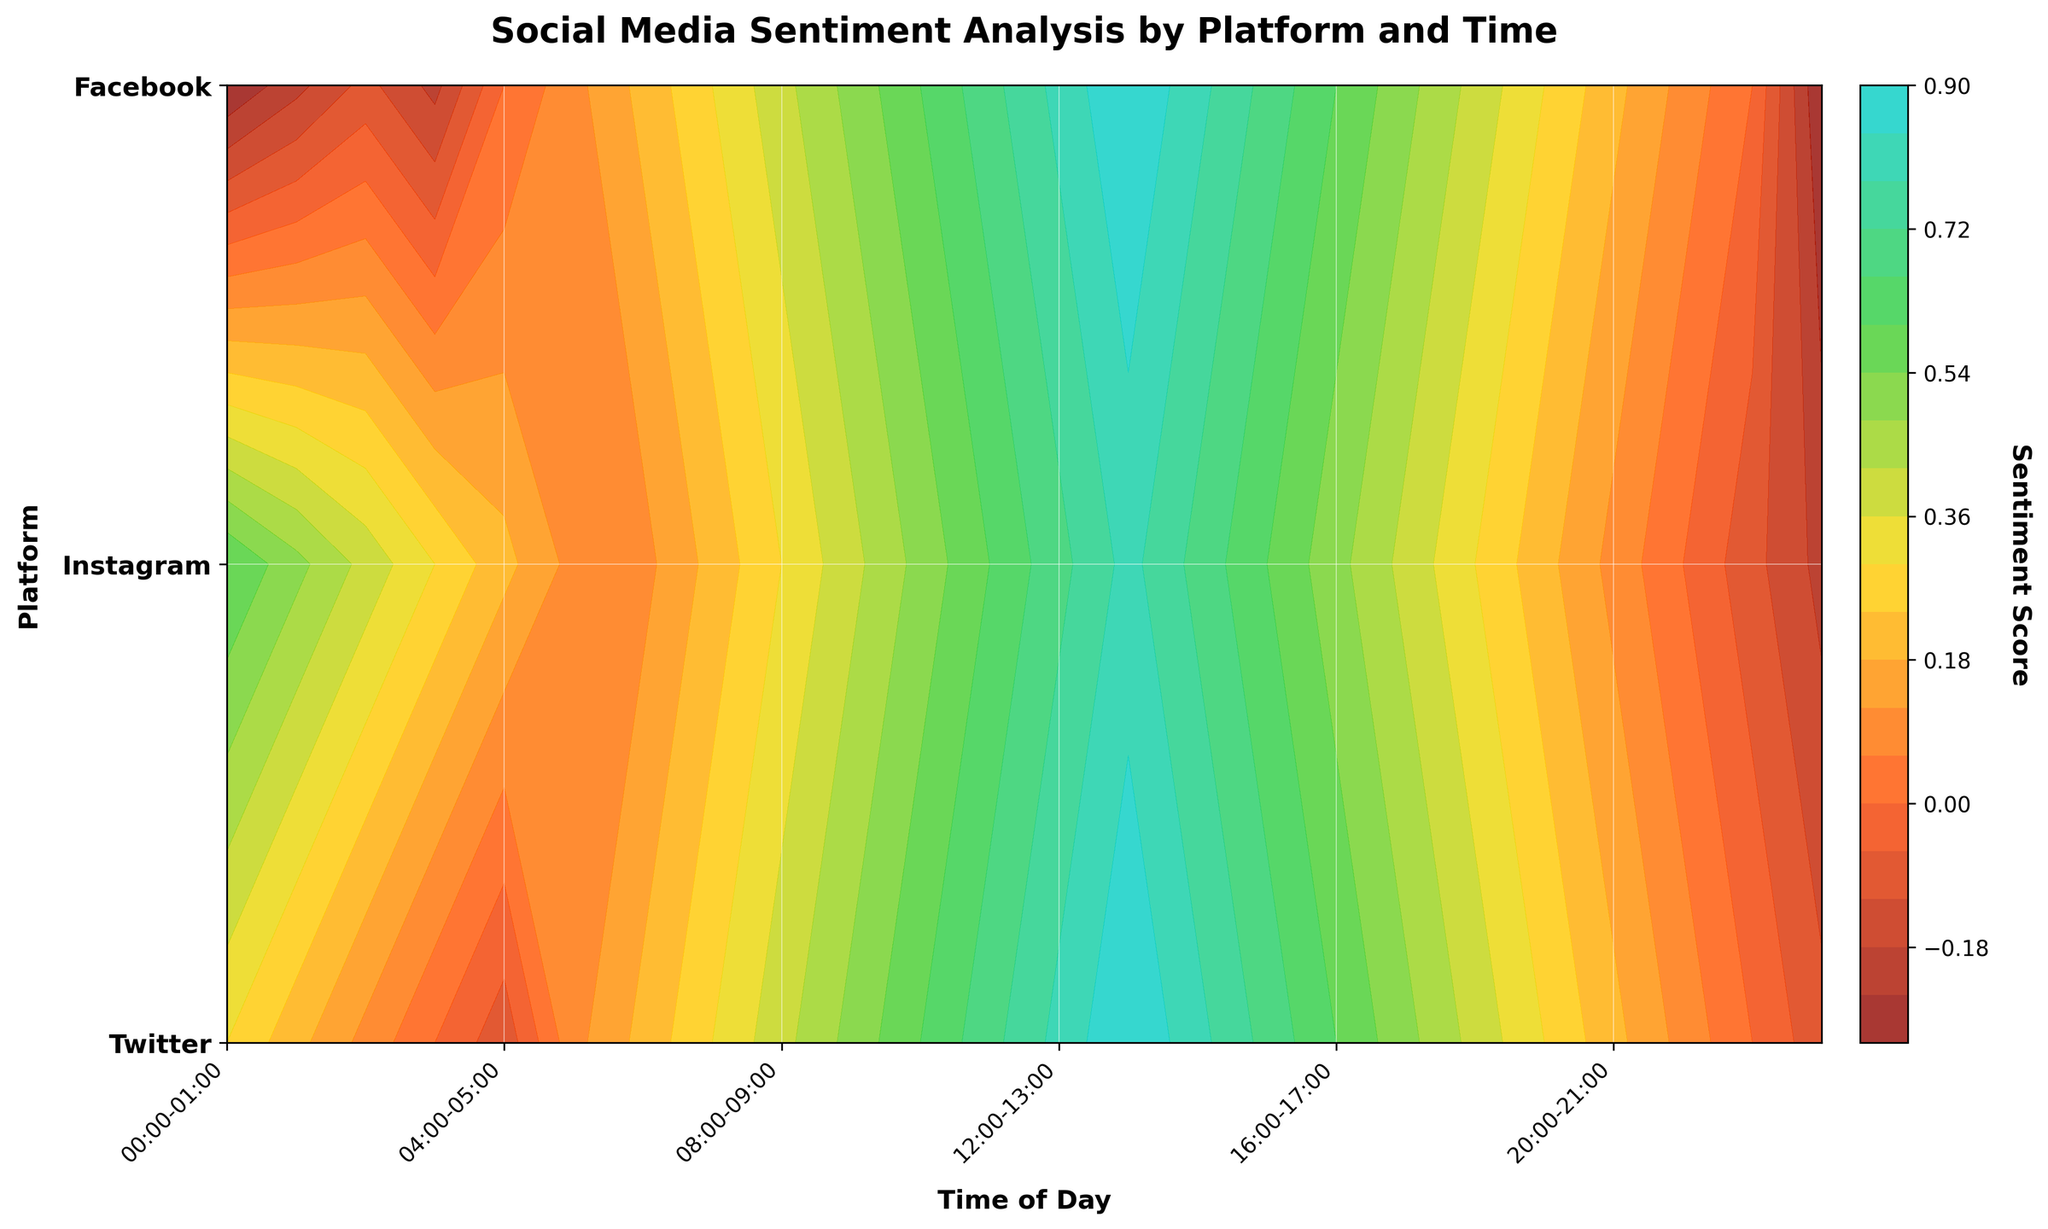What is the title of the plot? The title is located at the top center of the plot and is often in a larger and bold font.
Answer: 'Social Media Sentiment Analysis by Platform and Time' Which platform has the highest sentiment score at 12:00-13:00? The sentiment score for each platform at 12:00-13:00 can be identified by looking at the contour levels for that specific time slot. Twitter should have the highest value at this time.
Answer: Twitter During which time frame does Instagram show negative sentiment scores? Instagram's sentiment scores are negative if they fall below zero, which can be identified by the negative contour lines. This happens between 22:00-23:00 and 23:00-00:00.
Answer: 22:00-23:00 and 23:00-00:00 Compare the sentiment scores of Facebook and Twitter at 09:00-10:00. Which one is higher? To compare the sentiment scores at 09:00-10:00, examine the contour plot for the values corresponding to Facebook and Twitter at that time. Twitter has a sentiment score of 0.5 and Facebook 0.5, making them equal.
Answer: Both are equal What is the range of sentiment scores for Twitter throughout the day? By examining the contour labels for each time slot across the day for Twitter, you can see that the scores range from -0.3 to 0.9.
Answer: -0.3 to 0.9 How does the sentiment on Facebook change from 00:00-01:00 to 02:00-03:00? By looking at Facebook's sentiment scores at these time slots, it's clear the sentiment decreases from 0.3 at 00:00-01:00 to 0.1 at 02:00-03:00.
Answer: Decreases What is the overall trend in sentiment score throughout the day for Instagram? The overall trend for Instagram can be observed by examining the gradient of the contours: the sentiment generally decreases from a positive score and turns negative towards the end of the day.
Answer: Decreases Which platform shows the highest overall positive sentiment score during the day? Assessing the highest contour levels and their corresponding platforms, Twitter reaches a maximum sentiment score of 0.9 which is higher compared to the other platforms.
Answer: Twitter 